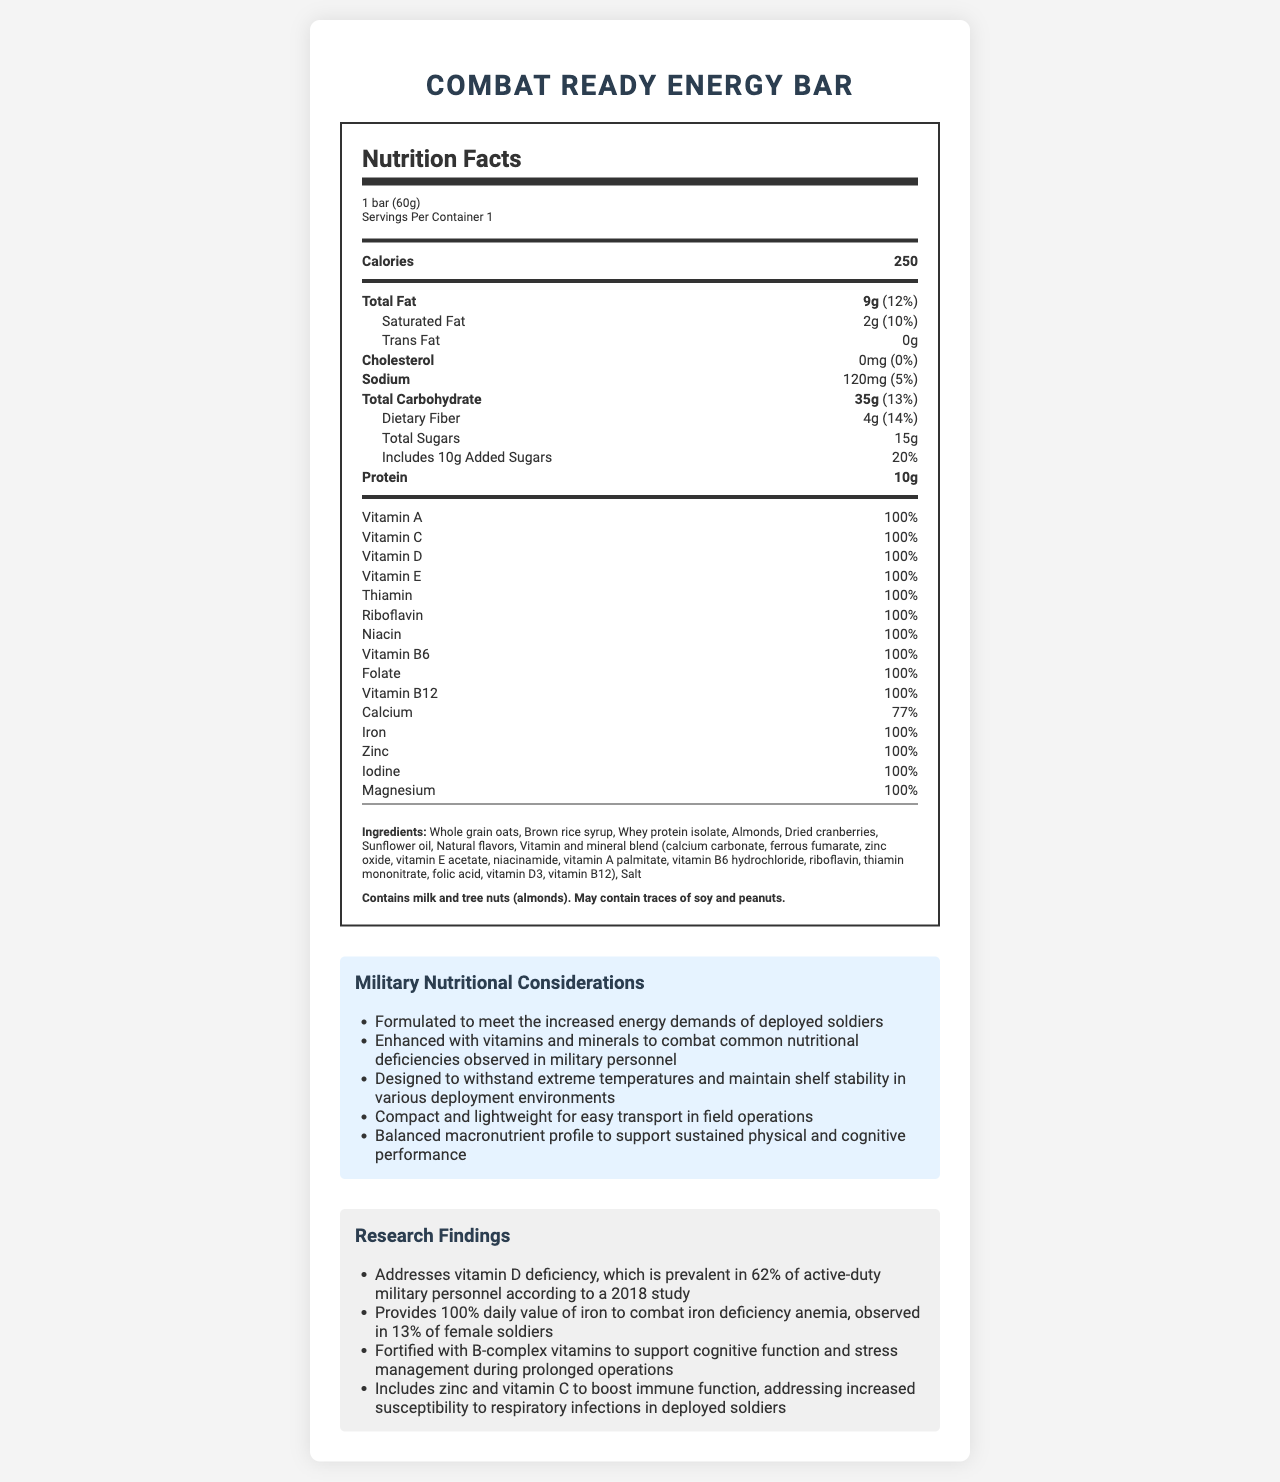what is the serving size for the Combat Ready Energy Bar? The serving size is listed as "1 bar (60g)" in the Nutrition Facts section.
Answer: 1 bar (60g) how many calories are in one serving of the Combat Ready Energy Bar? The calories per serving are stated as "250" in the Nutrition Facts section.
Answer: 250 what is the amount of protein in one serving? The amount of protein per serving is listed as "10g" in the Nutrition Facts section.
Answer: 10g Does the bar contain any added sugars? If so, how much? The Nutrition Facts section indicates that the bar includes "10g Added Sugars".
Answer: Yes, 10g Is there any trans fat in this energy bar? The amount of trans fat is stated as "0g" in the Nutrition Facts section.
Answer: No What percentage of the daily recommended intake of iron does the energy bar provide? A. 50% B. 77% C. 100% D. 14% The Nutrition Facts section indicates that the iron daily value is "100%".
Answer: C. 100% Which of the following vitamins is included at 100% of the daily value in the Combat Ready Energy Bar? (Choose all that apply.) I. Vitamin A II. Vitamin C III. Vitamin D IV. Vitamin E The Nutrition Facts section lists Vitamin A, Vitamin C, Vitamin D, and Vitamin E all at "100%" daily value.
Answer: I, II, III, IV Is the Combat Ready Energy Bar suitable for someone with a tree nut allergy? The allergen statement specifies that the bar "Contains milk and tree nuts (almonds)".
Answer: No Summarize the main idea of the document. The document includes multiple sections such as Nutrition Facts, ingredient list, allergen statement, military nutritional considerations, and research findings to help the reader understand the bar's benefits and suitability for military use.
Answer: The document provides detailed nutritional information about the Combat Ready Energy Bar, emphasizing its macronutrient and micronutrient content, ingredients, allergen information, and specific benefits designed for military personnel, such as energy provision, nutrient fortification, and suitability for field conditions. Does the bar contain any cholesterol? The Nutrition Facts section shows that the amount of cholesterol is "0mg" with a daily value of "0%".
Answer: No What is one of the reasons the Combat Ready Energy Bar includes zinc and vitamin C? A. To enhance flavor B. To boost immune function C. To increase caloric content D. To improve texture The research findings section states that zinc and vitamin C are included "to boost immune function".
Answer: B. To boost immune function What kind of magnesium compound is used in the Combat Ready Energy Bar? The document does not specify the type of magnesium compound used.
Answer: Not enough information How much calcium does one serving of the energy bar provide? The Nutrition Facts section lists "1000mg" of calcium in the energy bar.
Answer: 1000mg 